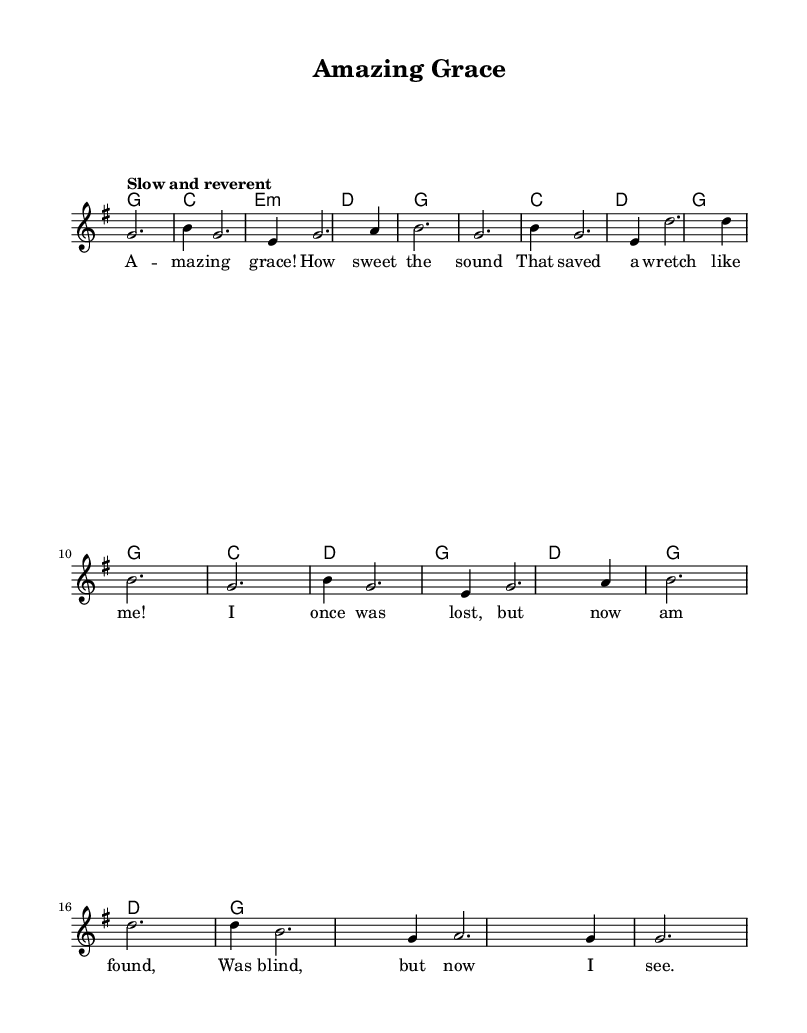What is the key signature of this music? The key signature is G major, which has one sharp (F sharp). This can be identified in the beginning of the sheet music where the accidentals are displayed.
Answer: G major What is the time signature of this music? The time signature is 3/4, indicating there are three beats in each measure and that each quarter note gets one beat. This is located at the beginning of the score right after the key signature.
Answer: 3/4 What tempo marking is given for this music? The tempo marking is "Slow and reverent," which indicates that the piece should be played at a slow pace, contributing to its reflective nature. This can be found above the staff in the tempo indications.
Answer: Slow and reverent How many measures are in the melody? There are 16 measures in the melody, which can be counted by analyzing the separation of the notes within the staff. Each group of notes surrounded by bar lines indicates a measure.
Answer: 16 What is the first lyric line of the song? The first lyric line of the song is "Amazing grace! How sweet the sound." Each line of lyrics corresponds with the melody notes beneath it, and the first line is the initial text under the notes.
Answer: Amazing grace! How sweet the sound Which chord appears most frequently in this piece? The chord G major appears most frequently throughout the piece, as evidenced by its repeated occurrence in the harmonic section of the score, showing its significance to the song's structure.
Answer: G major What emotional theme is represented in this song? The emotional theme represented in the song is redemption, as expressed through the lyrics detailing a transformation from being lost to found. This can be inferred from both the text and the overall context of the hymn.
Answer: Redemption 